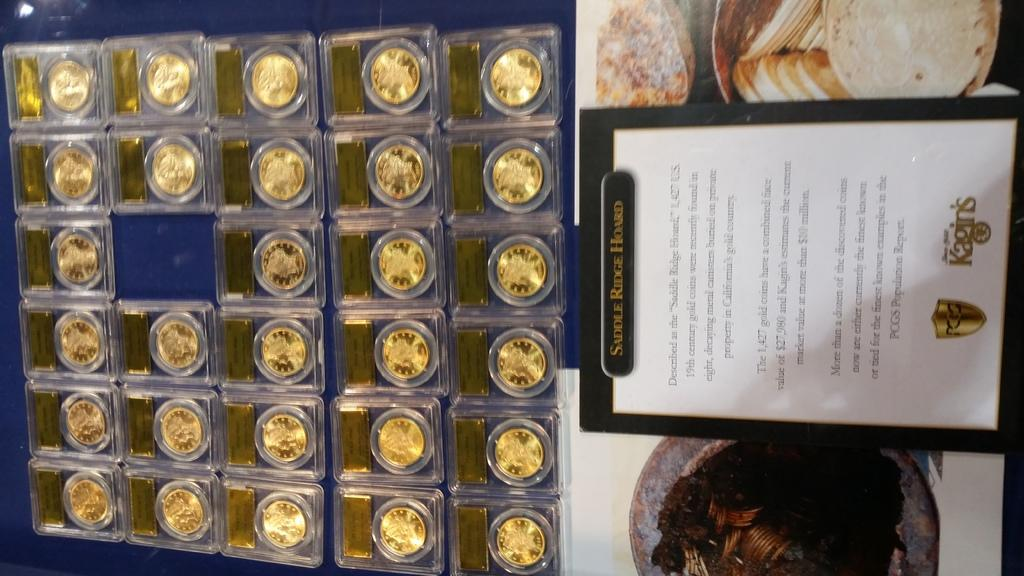<image>
Render a clear and concise summary of the photo. A collection of gold coins known as the Saddle Ridge Hoard 